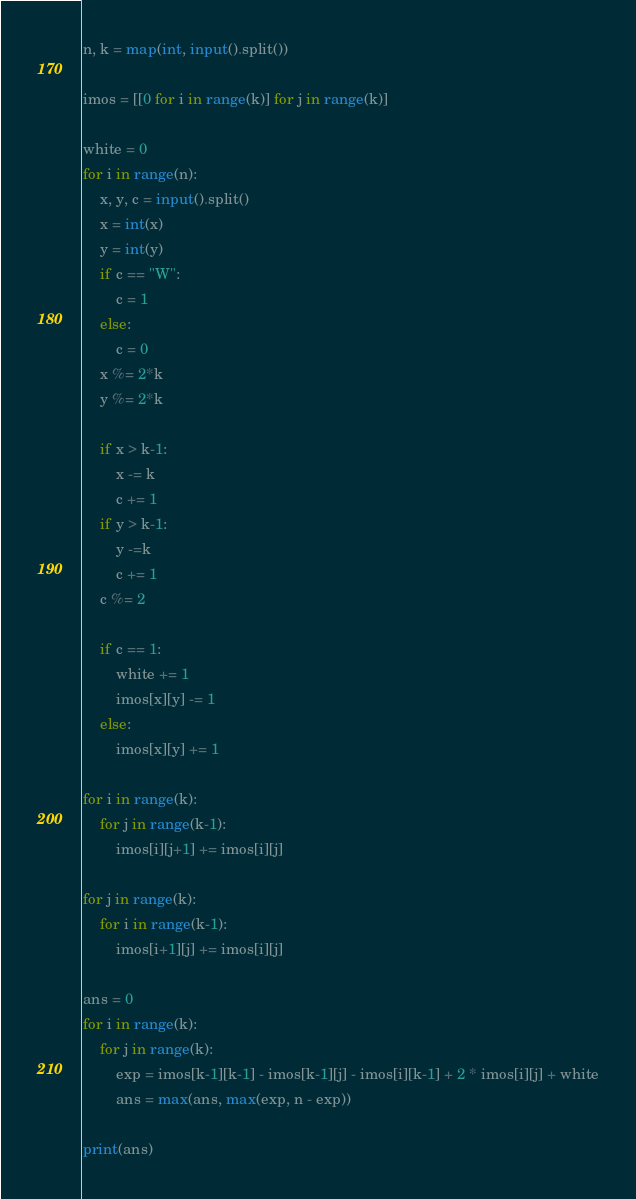<code> <loc_0><loc_0><loc_500><loc_500><_Python_>n, k = map(int, input().split())

imos = [[0 for i in range(k)] for j in range(k)]

white = 0
for i in range(n):
    x, y, c = input().split()
    x = int(x)
    y = int(y)
    if c == "W":
        c = 1
    else:
        c = 0
    x %= 2*k
    y %= 2*k

    if x > k-1:
        x -= k
        c += 1
    if y > k-1:
        y -=k
        c += 1
    c %= 2

    if c == 1:
        white += 1
        imos[x][y] -= 1
    else:
        imos[x][y] += 1

for i in range(k):
    for j in range(k-1):
        imos[i][j+1] += imos[i][j]

for j in range(k):
    for i in range(k-1):
        imos[i+1][j] += imos[i][j]

ans = 0
for i in range(k):
    for j in range(k):
        exp = imos[k-1][k-1] - imos[k-1][j] - imos[i][k-1] + 2 * imos[i][j] + white
        ans = max(ans, max(exp, n - exp))

print(ans)</code> 